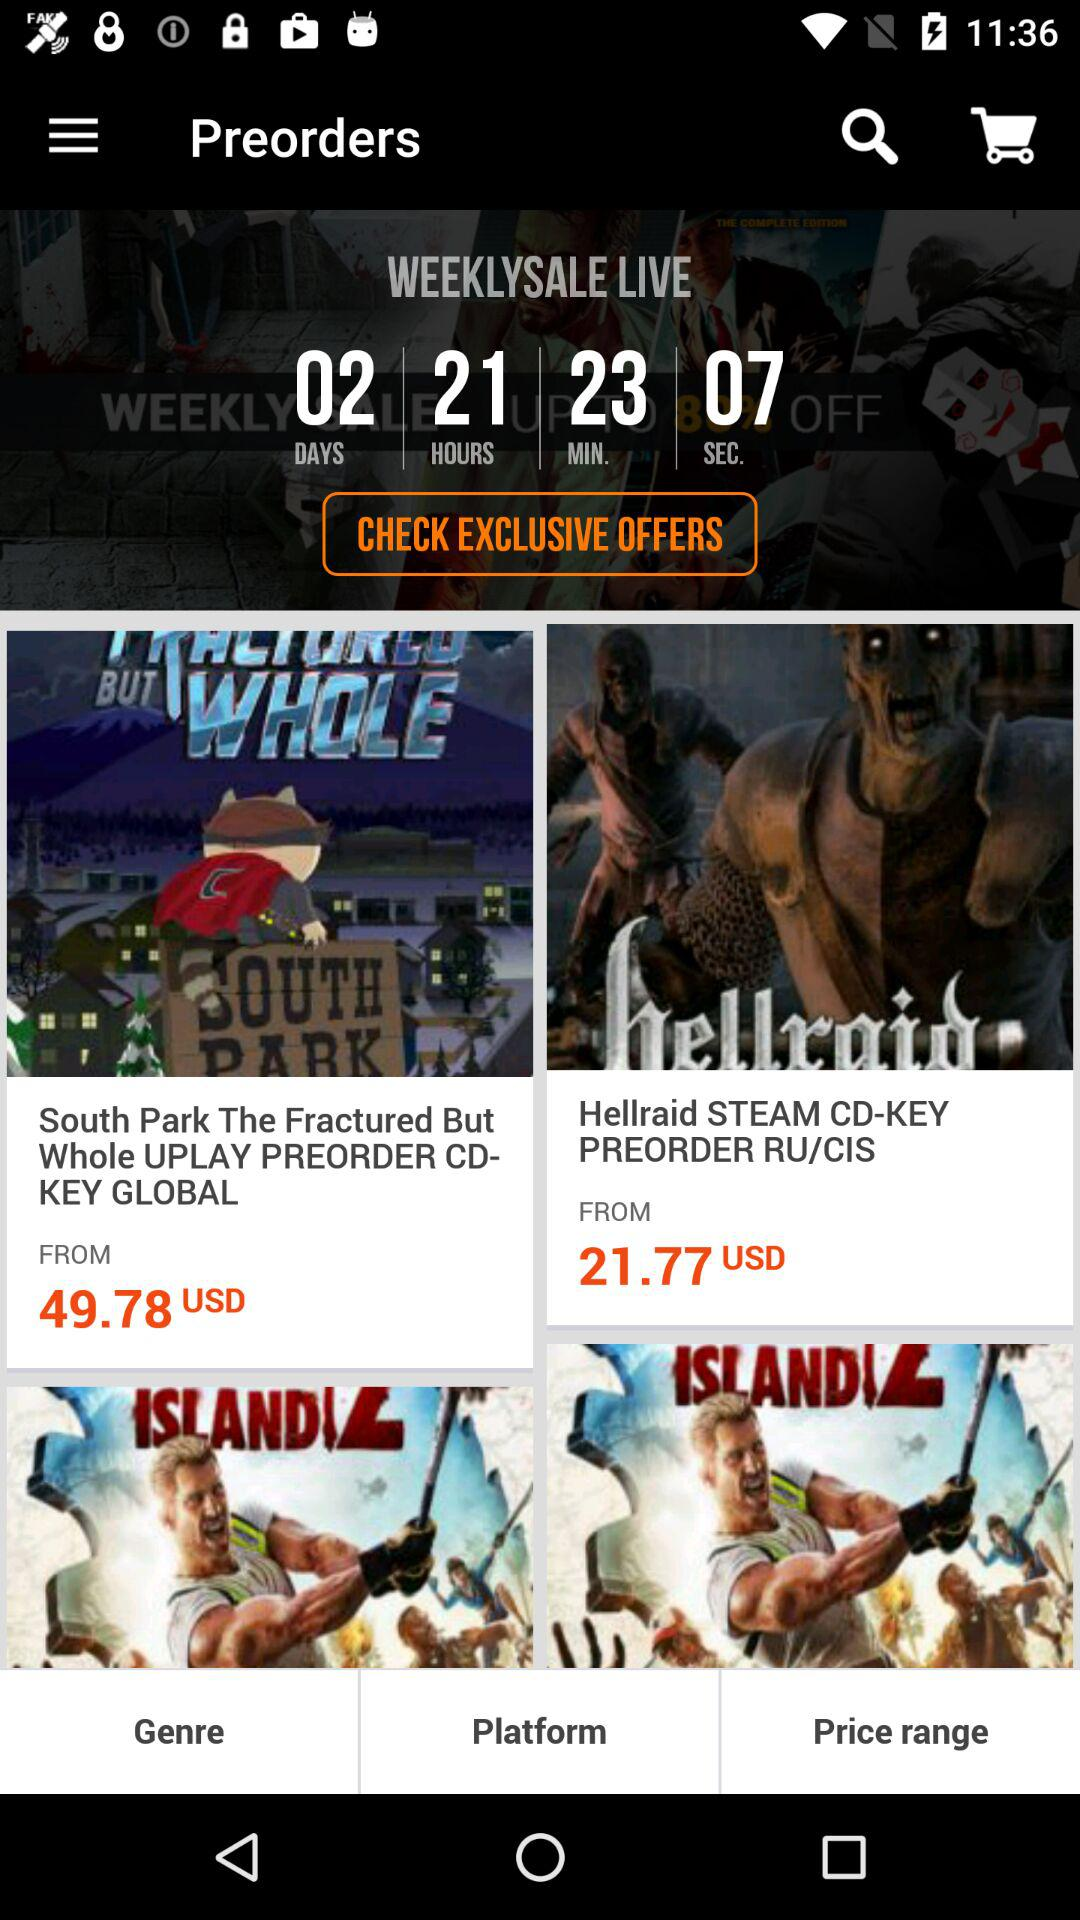What is the starting price of "South Park The Fractured But Whole" in USD? The starting price of "South Park The Fractured But Whole" is 49.78 USD. 